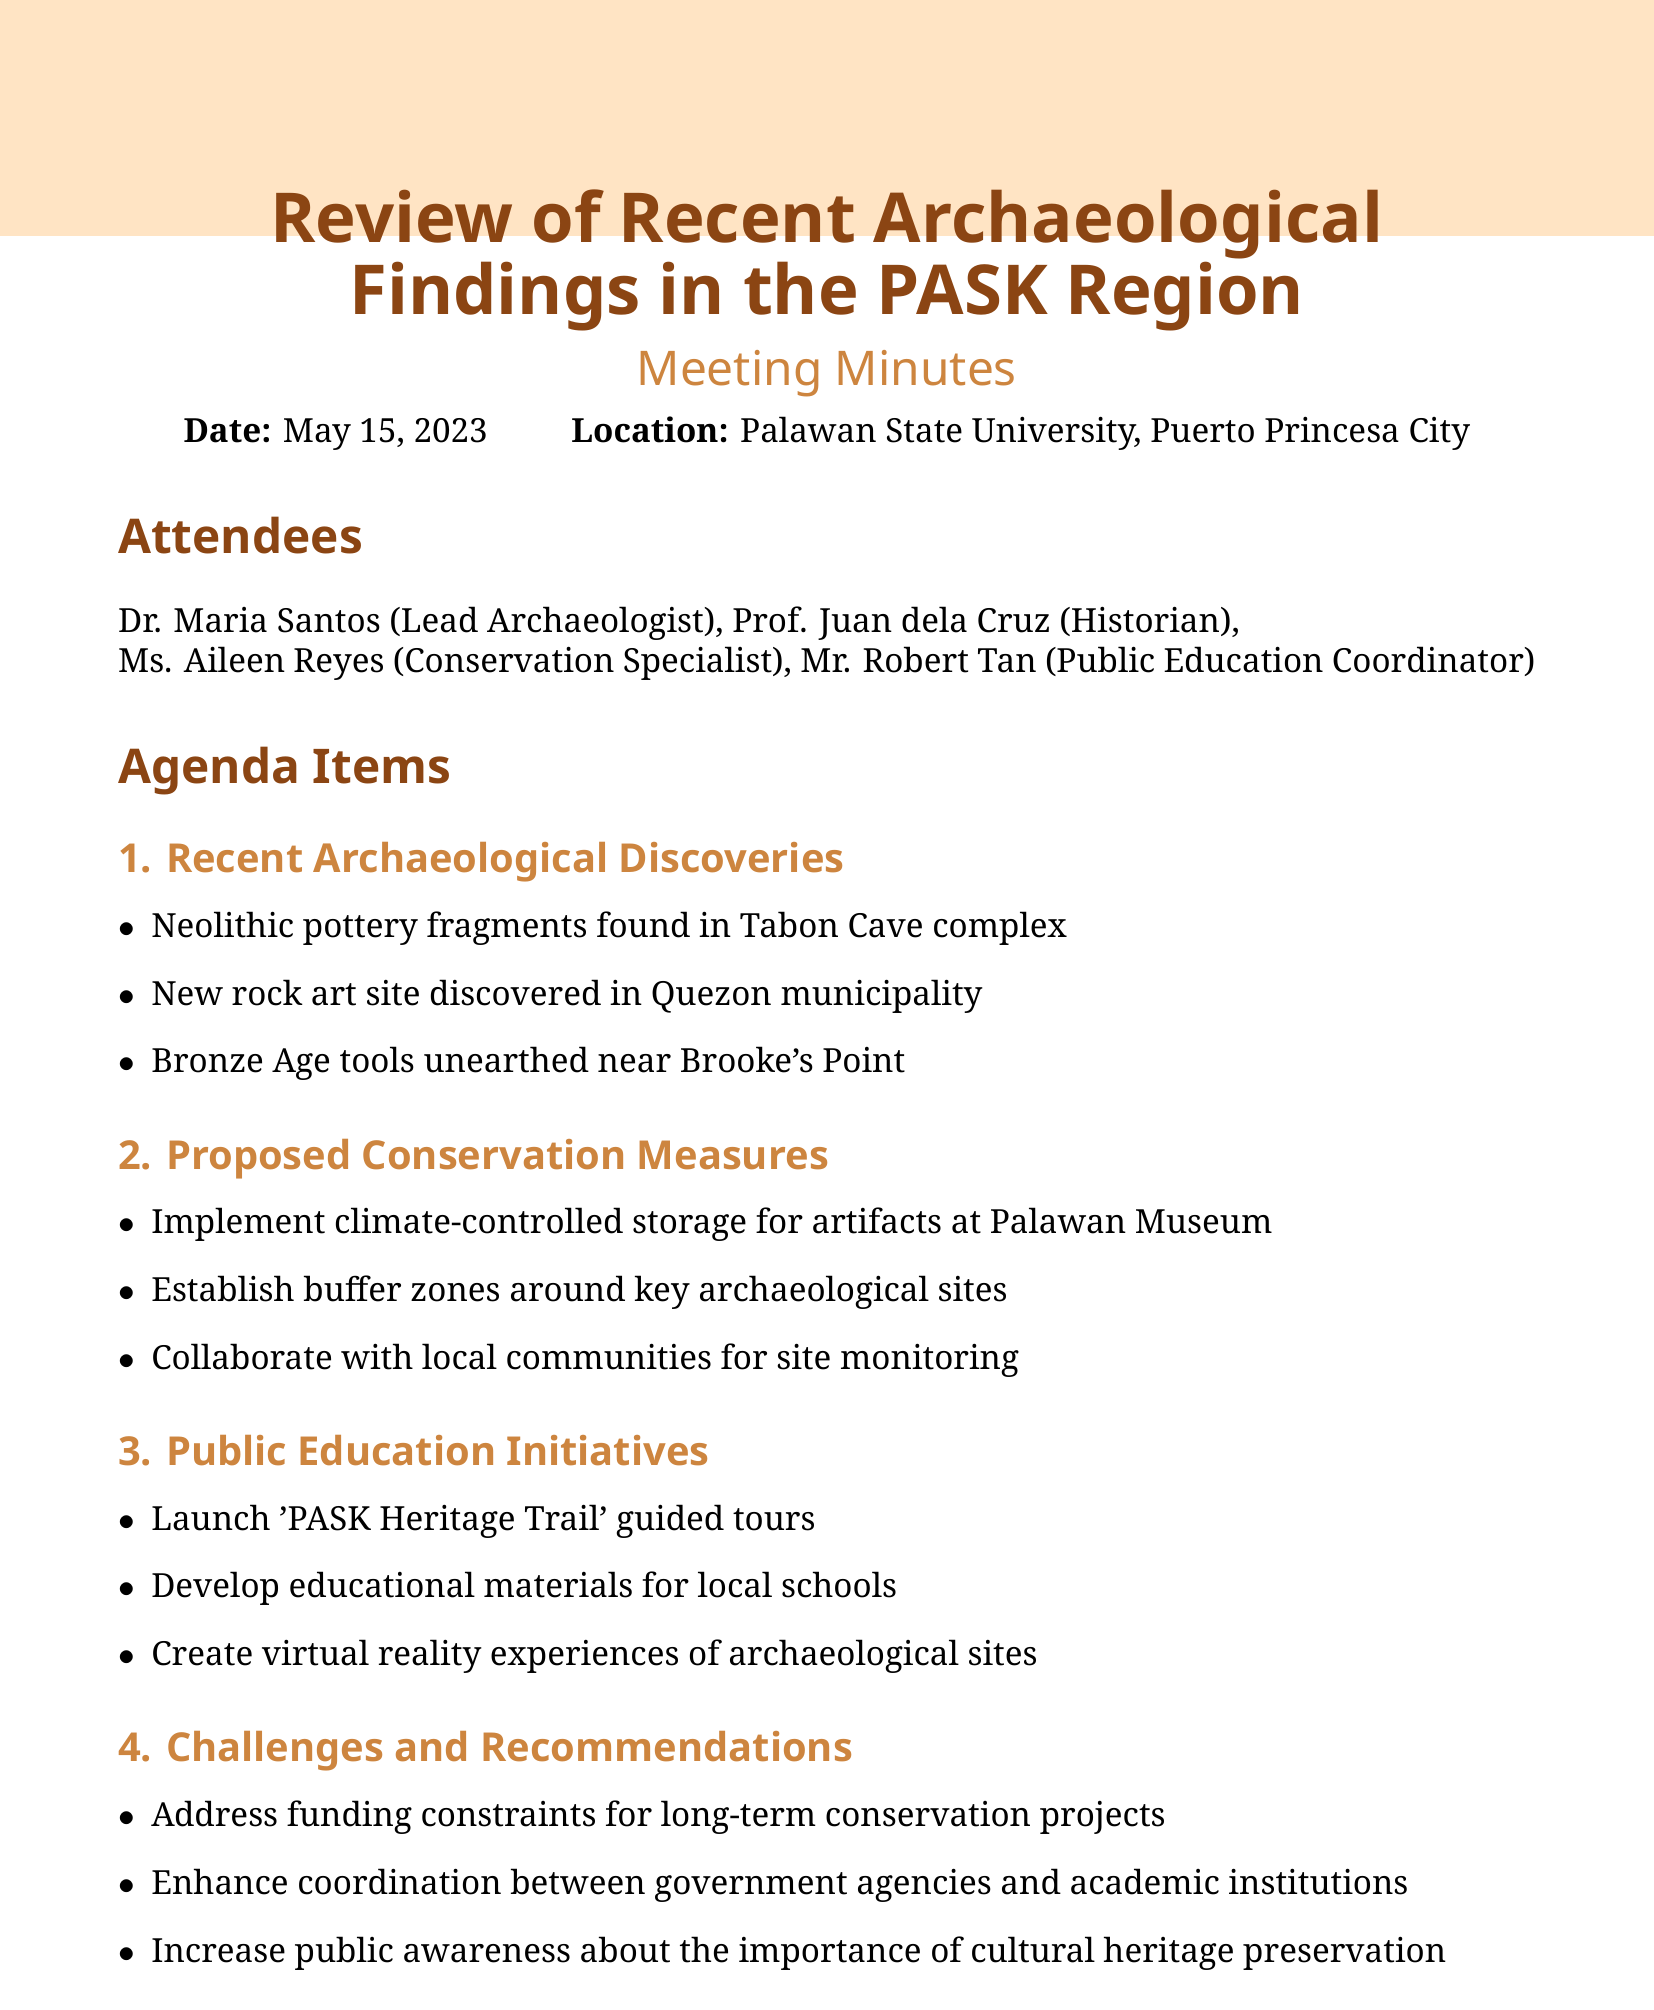what is the date of the meeting? The date of the meeting is explicitly stated in the document header.
Answer: May 15, 2023 who is the Lead Archaeologist? The document lists the attendees and their roles, identifying the Lead Archaeologist.
Answer: Dr. Maria Santos what were found in Tabon Cave complex? The specific archaeological discovery mentioned in the document refers to items found in this location.
Answer: Neolithic pottery fragments what is one proposed conservation measure? The document outlines several proposed measures for conservation, needing just one example.
Answer: Implement climate-controlled storage for artifacts at Palawan Museum what public education initiative is planned? The document lists initiatives aimed at public education, including a specific planned initiative.
Answer: Launch 'PASK Heritage Trail' guided tours how many action items are listed? The action items section lists specific tasks to be completed, allowing for a count.
Answer: 3 which municipality has a newly discovered rock art site? The document mentions the municipality where the new rock art site was found, providing a clear answer.
Answer: Quezon when is the next meeting scheduled? The next meeting date is provided at the end of the document, indicating future planning.
Answer: August 15, 2023 